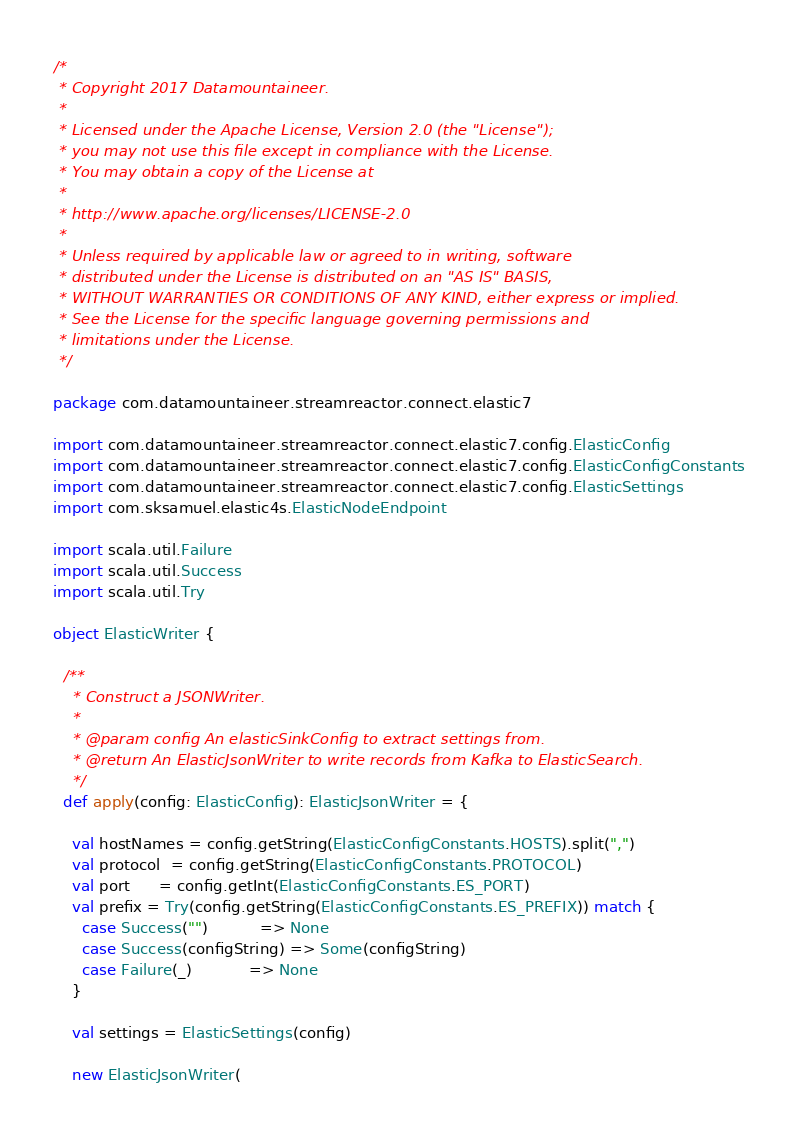Convert code to text. <code><loc_0><loc_0><loc_500><loc_500><_Scala_>/*
 * Copyright 2017 Datamountaineer.
 *
 * Licensed under the Apache License, Version 2.0 (the "License");
 * you may not use this file except in compliance with the License.
 * You may obtain a copy of the License at
 *
 * http://www.apache.org/licenses/LICENSE-2.0
 *
 * Unless required by applicable law or agreed to in writing, software
 * distributed under the License is distributed on an "AS IS" BASIS,
 * WITHOUT WARRANTIES OR CONDITIONS OF ANY KIND, either express or implied.
 * See the License for the specific language governing permissions and
 * limitations under the License.
 */

package com.datamountaineer.streamreactor.connect.elastic7

import com.datamountaineer.streamreactor.connect.elastic7.config.ElasticConfig
import com.datamountaineer.streamreactor.connect.elastic7.config.ElasticConfigConstants
import com.datamountaineer.streamreactor.connect.elastic7.config.ElasticSettings
import com.sksamuel.elastic4s.ElasticNodeEndpoint

import scala.util.Failure
import scala.util.Success
import scala.util.Try

object ElasticWriter {

  /**
    * Construct a JSONWriter.
    *
    * @param config An elasticSinkConfig to extract settings from.
    * @return An ElasticJsonWriter to write records from Kafka to ElasticSearch.
    */
  def apply(config: ElasticConfig): ElasticJsonWriter = {

    val hostNames = config.getString(ElasticConfigConstants.HOSTS).split(",")
    val protocol  = config.getString(ElasticConfigConstants.PROTOCOL)
    val port      = config.getInt(ElasticConfigConstants.ES_PORT)
    val prefix = Try(config.getString(ElasticConfigConstants.ES_PREFIX)) match {
      case Success("")           => None
      case Success(configString) => Some(configString)
      case Failure(_)            => None
    }

    val settings = ElasticSettings(config)

    new ElasticJsonWriter(</code> 